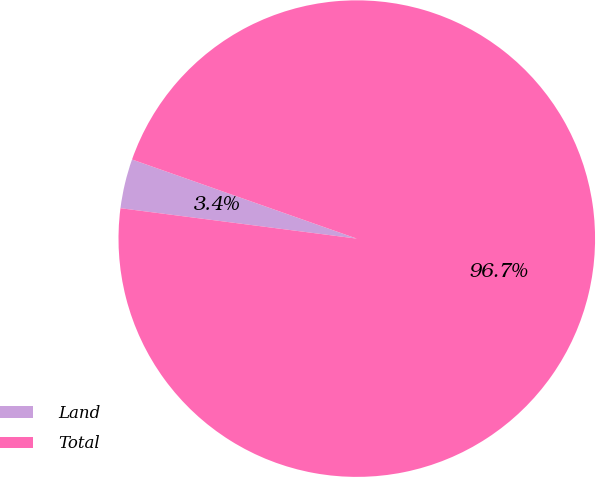<chart> <loc_0><loc_0><loc_500><loc_500><pie_chart><fcel>Land<fcel>Total<nl><fcel>3.35%<fcel>96.65%<nl></chart> 